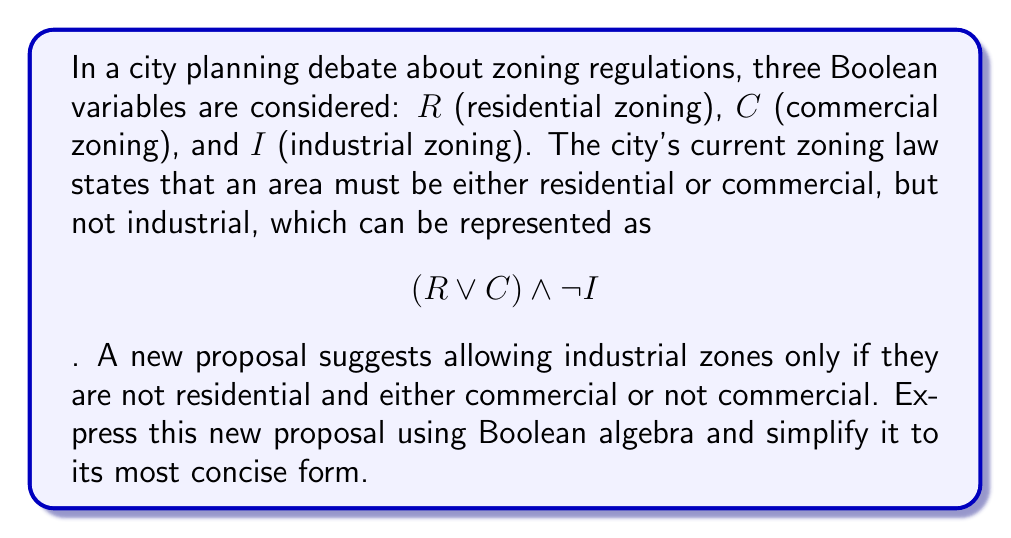Can you solve this math problem? Let's approach this step-by-step:

1) First, let's translate the new proposal into Boolean algebra:
   "Industrial zones only if they are not residential and either commercial or not commercial"
   This can be written as: $I \rightarrow (\lnot R \land (C \lor \lnot C))$

2) We can rewrite this implication as a disjunction:
   $\lnot I \lor (\lnot R \land (C \lor \lnot C))$

3) Now, let's focus on the $(C \lor \lnot C)$ part. This is a tautology in Boolean algebra, always evaluating to true. We can replace it with 1:
   $\lnot I \lor (\lnot R \land 1)$

4) Simplify:
   $\lnot I \lor \lnot R$

5) Using De Morgan's law, we can rewrite this as:
   $\lnot(I \land R)$

This final form, $\lnot(I \land R)$, is the most concise expression of the new proposal. It states that an area cannot be both industrial and residential, but allows for any other combination.
Answer: $\lnot(I \land R)$ 